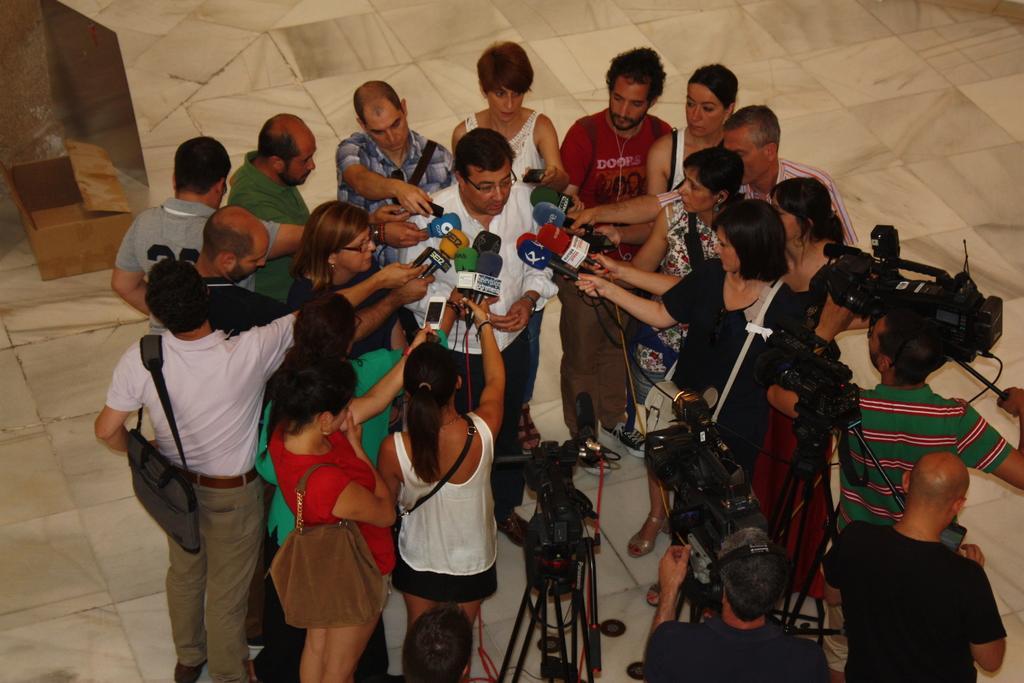Please provide a concise description of this image. In the foreground of this image, there is a man in the middle around which there are people standing and holding mics. At the bottom, there are few men standing and also we can see cameras to the stand on the floor. 